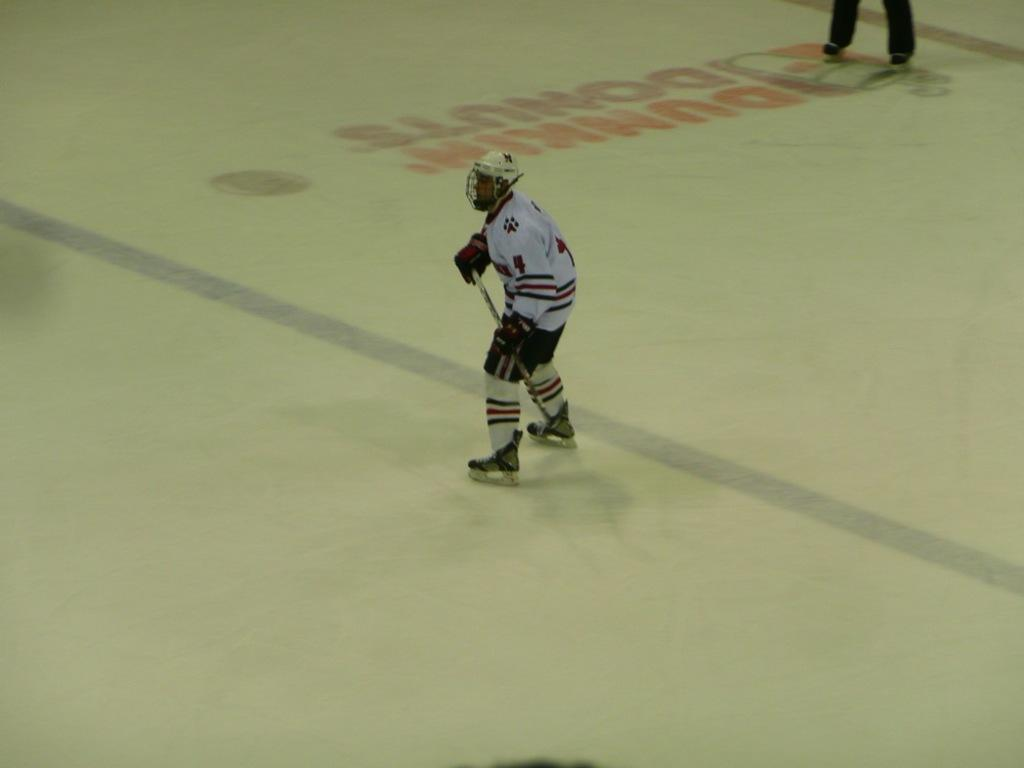<image>
Render a clear and concise summary of the photo. a hockey player with 4 on his jersey 